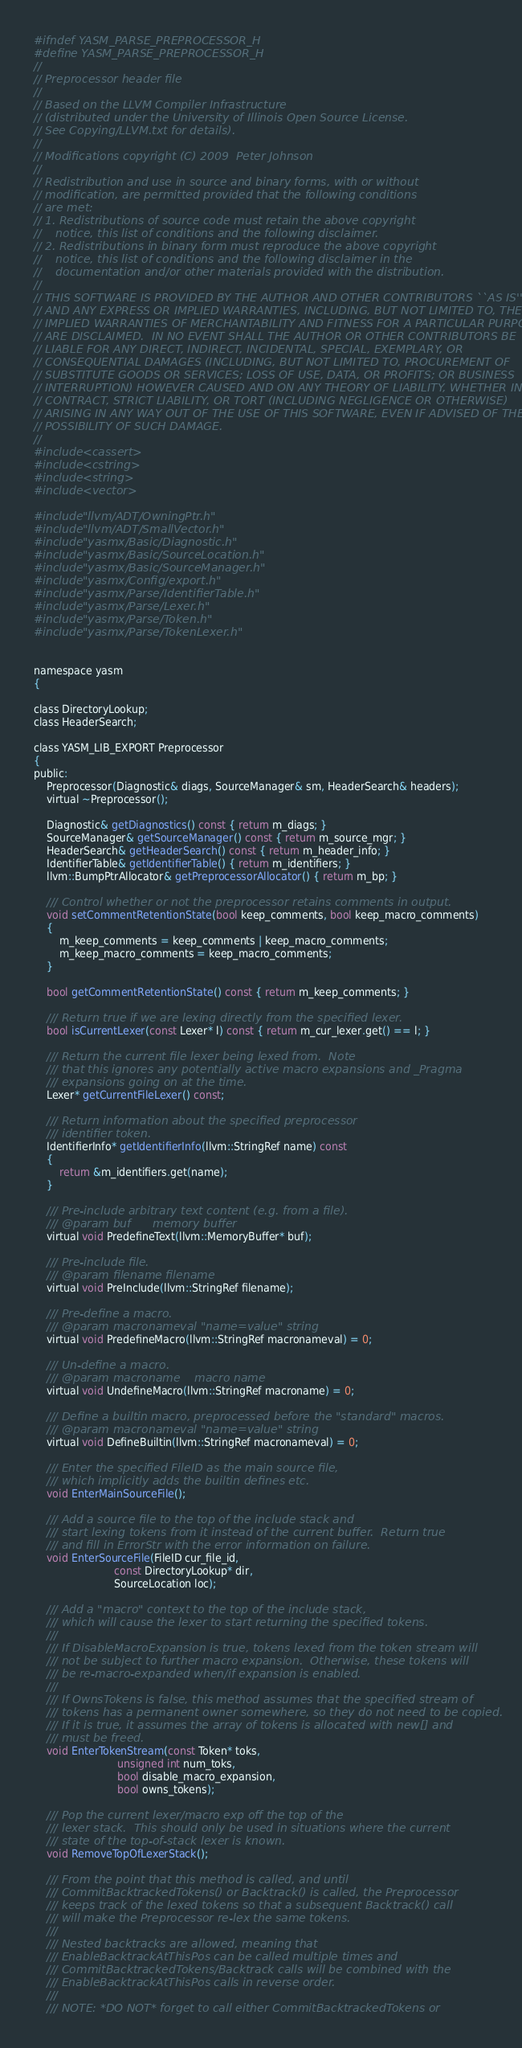<code> <loc_0><loc_0><loc_500><loc_500><_C_>#ifndef YASM_PARSE_PREPROCESSOR_H
#define YASM_PARSE_PREPROCESSOR_H
//
// Preprocessor header file
//
// Based on the LLVM Compiler Infrastructure
// (distributed under the University of Illinois Open Source License.
// See Copying/LLVM.txt for details).
//
// Modifications copyright (C) 2009  Peter Johnson
//
// Redistribution and use in source and binary forms, with or without
// modification, are permitted provided that the following conditions
// are met:
// 1. Redistributions of source code must retain the above copyright
//    notice, this list of conditions and the following disclaimer.
// 2. Redistributions in binary form must reproduce the above copyright
//    notice, this list of conditions and the following disclaimer in the
//    documentation and/or other materials provided with the distribution.
//
// THIS SOFTWARE IS PROVIDED BY THE AUTHOR AND OTHER CONTRIBUTORS ``AS IS''
// AND ANY EXPRESS OR IMPLIED WARRANTIES, INCLUDING, BUT NOT LIMITED TO, THE
// IMPLIED WARRANTIES OF MERCHANTABILITY AND FITNESS FOR A PARTICULAR PURPOSE
// ARE DISCLAIMED.  IN NO EVENT SHALL THE AUTHOR OR OTHER CONTRIBUTORS BE
// LIABLE FOR ANY DIRECT, INDIRECT, INCIDENTAL, SPECIAL, EXEMPLARY, OR
// CONSEQUENTIAL DAMAGES (INCLUDING, BUT NOT LIMITED TO, PROCUREMENT OF
// SUBSTITUTE GOODS OR SERVICES; LOSS OF USE, DATA, OR PROFITS; OR BUSINESS
// INTERRUPTION) HOWEVER CAUSED AND ON ANY THEORY OF LIABILITY, WHETHER IN
// CONTRACT, STRICT LIABILITY, OR TORT (INCLUDING NEGLIGENCE OR OTHERWISE)
// ARISING IN ANY WAY OUT OF THE USE OF THIS SOFTWARE, EVEN IF ADVISED OF THE
// POSSIBILITY OF SUCH DAMAGE.
//
#include <cassert>
#include <cstring>
#include <string>
#include <vector>

#include "llvm/ADT/OwningPtr.h"
#include "llvm/ADT/SmallVector.h"
#include "yasmx/Basic/Diagnostic.h"
#include "yasmx/Basic/SourceLocation.h"
#include "yasmx/Basic/SourceManager.h"
#include "yasmx/Config/export.h"
#include "yasmx/Parse/IdentifierTable.h"
#include "yasmx/Parse/Lexer.h"
#include "yasmx/Parse/Token.h"
#include "yasmx/Parse/TokenLexer.h"


namespace yasm
{

class DirectoryLookup;
class HeaderSearch;

class YASM_LIB_EXPORT Preprocessor
{
public:
    Preprocessor(Diagnostic& diags, SourceManager& sm, HeaderSearch& headers);
    virtual ~Preprocessor();

    Diagnostic& getDiagnostics() const { return m_diags; }
    SourceManager& getSourceManager() const { return m_source_mgr; }
    HeaderSearch& getHeaderSearch() const { return m_header_info; }
    IdentifierTable& getIdentifierTable() { return m_identifiers; }
    llvm::BumpPtrAllocator& getPreprocessorAllocator() { return m_bp; }

    /// Control whether or not the preprocessor retains comments in output.
    void setCommentRetentionState(bool keep_comments, bool keep_macro_comments)
    {
        m_keep_comments = keep_comments | keep_macro_comments;
        m_keep_macro_comments = keep_macro_comments;
    }
  
    bool getCommentRetentionState() const { return m_keep_comments; }
  
    /// Return true if we are lexing directly from the specified lexer.
    bool isCurrentLexer(const Lexer* l) const { return m_cur_lexer.get() == l; }

    /// Return the current file lexer being lexed from.  Note
    /// that this ignores any potentially active macro expansions and _Pragma
    /// expansions going on at the time.
    Lexer* getCurrentFileLexer() const;

    /// Return information about the specified preprocessor
    /// identifier token.
    IdentifierInfo* getIdentifierInfo(llvm::StringRef name) const
    {
        return &m_identifiers.get(name);
    }

    /// Pre-include arbitrary text content (e.g. from a file).
    /// @param buf      memory buffer
    virtual void PredefineText(llvm::MemoryBuffer* buf);

    /// Pre-include file.
    /// @param filename filename
    virtual void PreInclude(llvm::StringRef filename);

    /// Pre-define a macro.
    /// @param macronameval "name=value" string
    virtual void PredefineMacro(llvm::StringRef macronameval) = 0;

    /// Un-define a macro.
    /// @param macroname    macro name
    virtual void UndefineMacro(llvm::StringRef macroname) = 0;

    /// Define a builtin macro, preprocessed before the "standard" macros.
    /// @param macronameval "name=value" string
    virtual void DefineBuiltin(llvm::StringRef macronameval) = 0;

    /// Enter the specified FileID as the main source file,
    /// which implicitly adds the builtin defines etc.
    void EnterMainSourceFile();
  
    /// Add a source file to the top of the include stack and
    /// start lexing tokens from it instead of the current buffer.  Return true
    /// and fill in ErrorStr with the error information on failure.
    void EnterSourceFile(FileID cur_file_id,
                         const DirectoryLookup* dir,
                         SourceLocation loc);

    /// Add a "macro" context to the top of the include stack,
    /// which will cause the lexer to start returning the specified tokens.
    ///
    /// If DisableMacroExpansion is true, tokens lexed from the token stream will
    /// not be subject to further macro expansion.  Otherwise, these tokens will
    /// be re-macro-expanded when/if expansion is enabled.
    ///
    /// If OwnsTokens is false, this method assumes that the specified stream of
    /// tokens has a permanent owner somewhere, so they do not need to be copied.
    /// If it is true, it assumes the array of tokens is allocated with new[] and
    /// must be freed.
    void EnterTokenStream(const Token* toks,
                          unsigned int num_toks,
                          bool disable_macro_expansion,
                          bool owns_tokens);

    /// Pop the current lexer/macro exp off the top of the
    /// lexer stack.  This should only be used in situations where the current
    /// state of the top-of-stack lexer is known.
    void RemoveTopOfLexerStack();

    /// From the point that this method is called, and until
    /// CommitBacktrackedTokens() or Backtrack() is called, the Preprocessor
    /// keeps track of the lexed tokens so that a subsequent Backtrack() call
    /// will make the Preprocessor re-lex the same tokens.
    ///
    /// Nested backtracks are allowed, meaning that
    /// EnableBacktrackAtThisPos can be called multiple times and
    /// CommitBacktrackedTokens/Backtrack calls will be combined with the
    /// EnableBacktrackAtThisPos calls in reverse order.
    ///
    /// NOTE: *DO NOT* forget to call either CommitBacktrackedTokens or</code> 